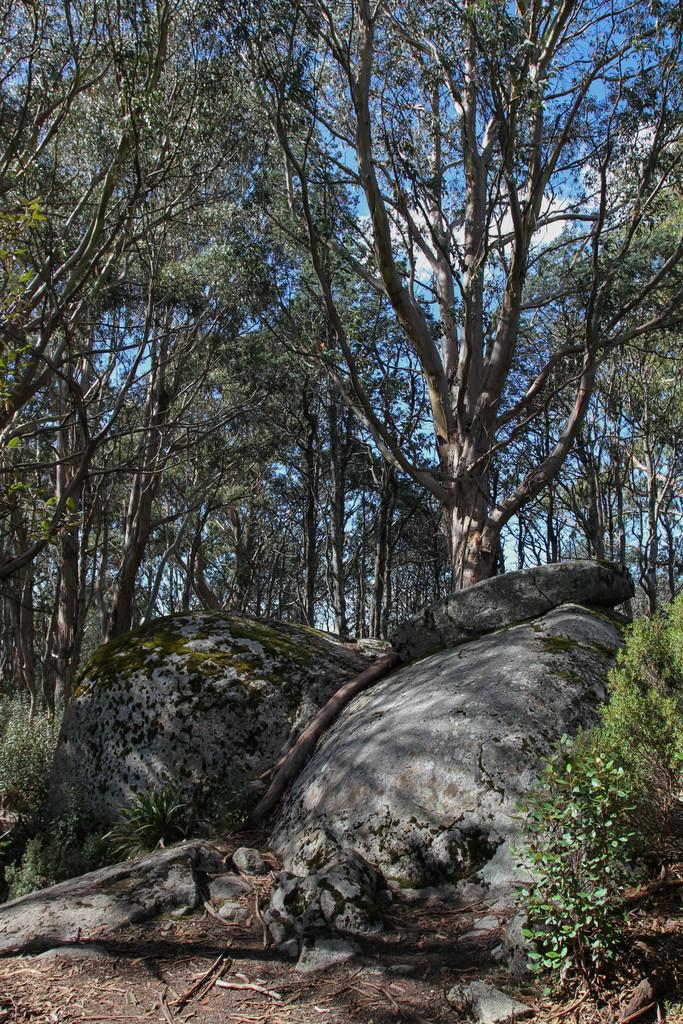What can be seen in the foreground of the image? There are stones and plants in the foreground of the image. What else is present in the foreground of the image? There are no other objects or features mentioned in the provided facts. What can be seen in the background of the image? There are trees and the sky visible in the background of the image. Can you describe the sky in the image? The sky is visible in the background of the image, and there is a cloud visible in the sky. What type of polish is being applied to the plants in the image? There is no mention of any polish being applied to the plants in the image. How does the plant on the slope in the image look? There is no slope or specific plant mentioned in the provided facts, so it is not possible to answer this question. 